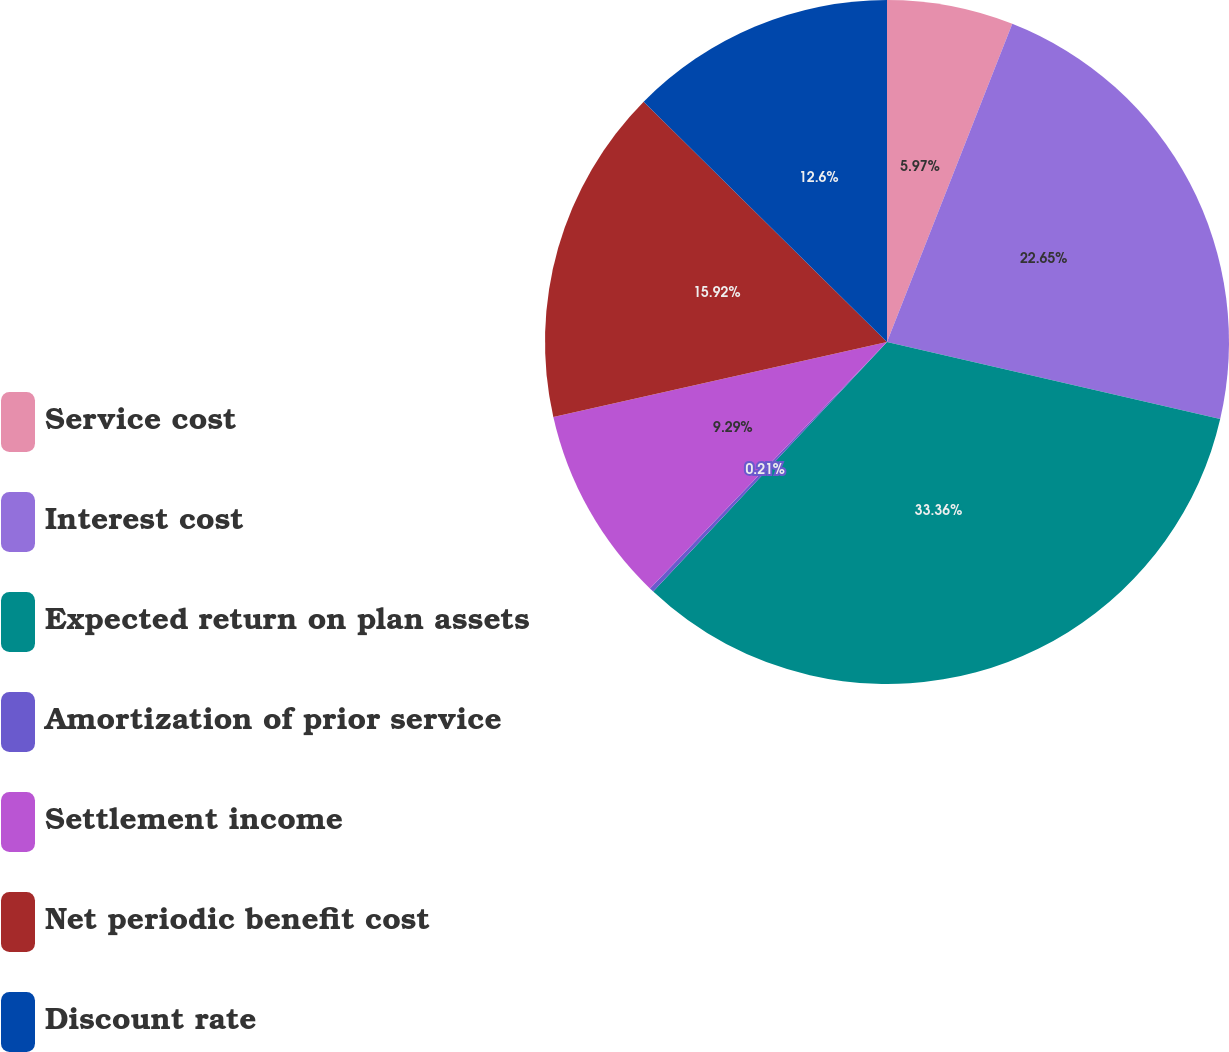Convert chart to OTSL. <chart><loc_0><loc_0><loc_500><loc_500><pie_chart><fcel>Service cost<fcel>Interest cost<fcel>Expected return on plan assets<fcel>Amortization of prior service<fcel>Settlement income<fcel>Net periodic benefit cost<fcel>Discount rate<nl><fcel>5.97%<fcel>22.65%<fcel>33.36%<fcel>0.21%<fcel>9.29%<fcel>15.92%<fcel>12.6%<nl></chart> 